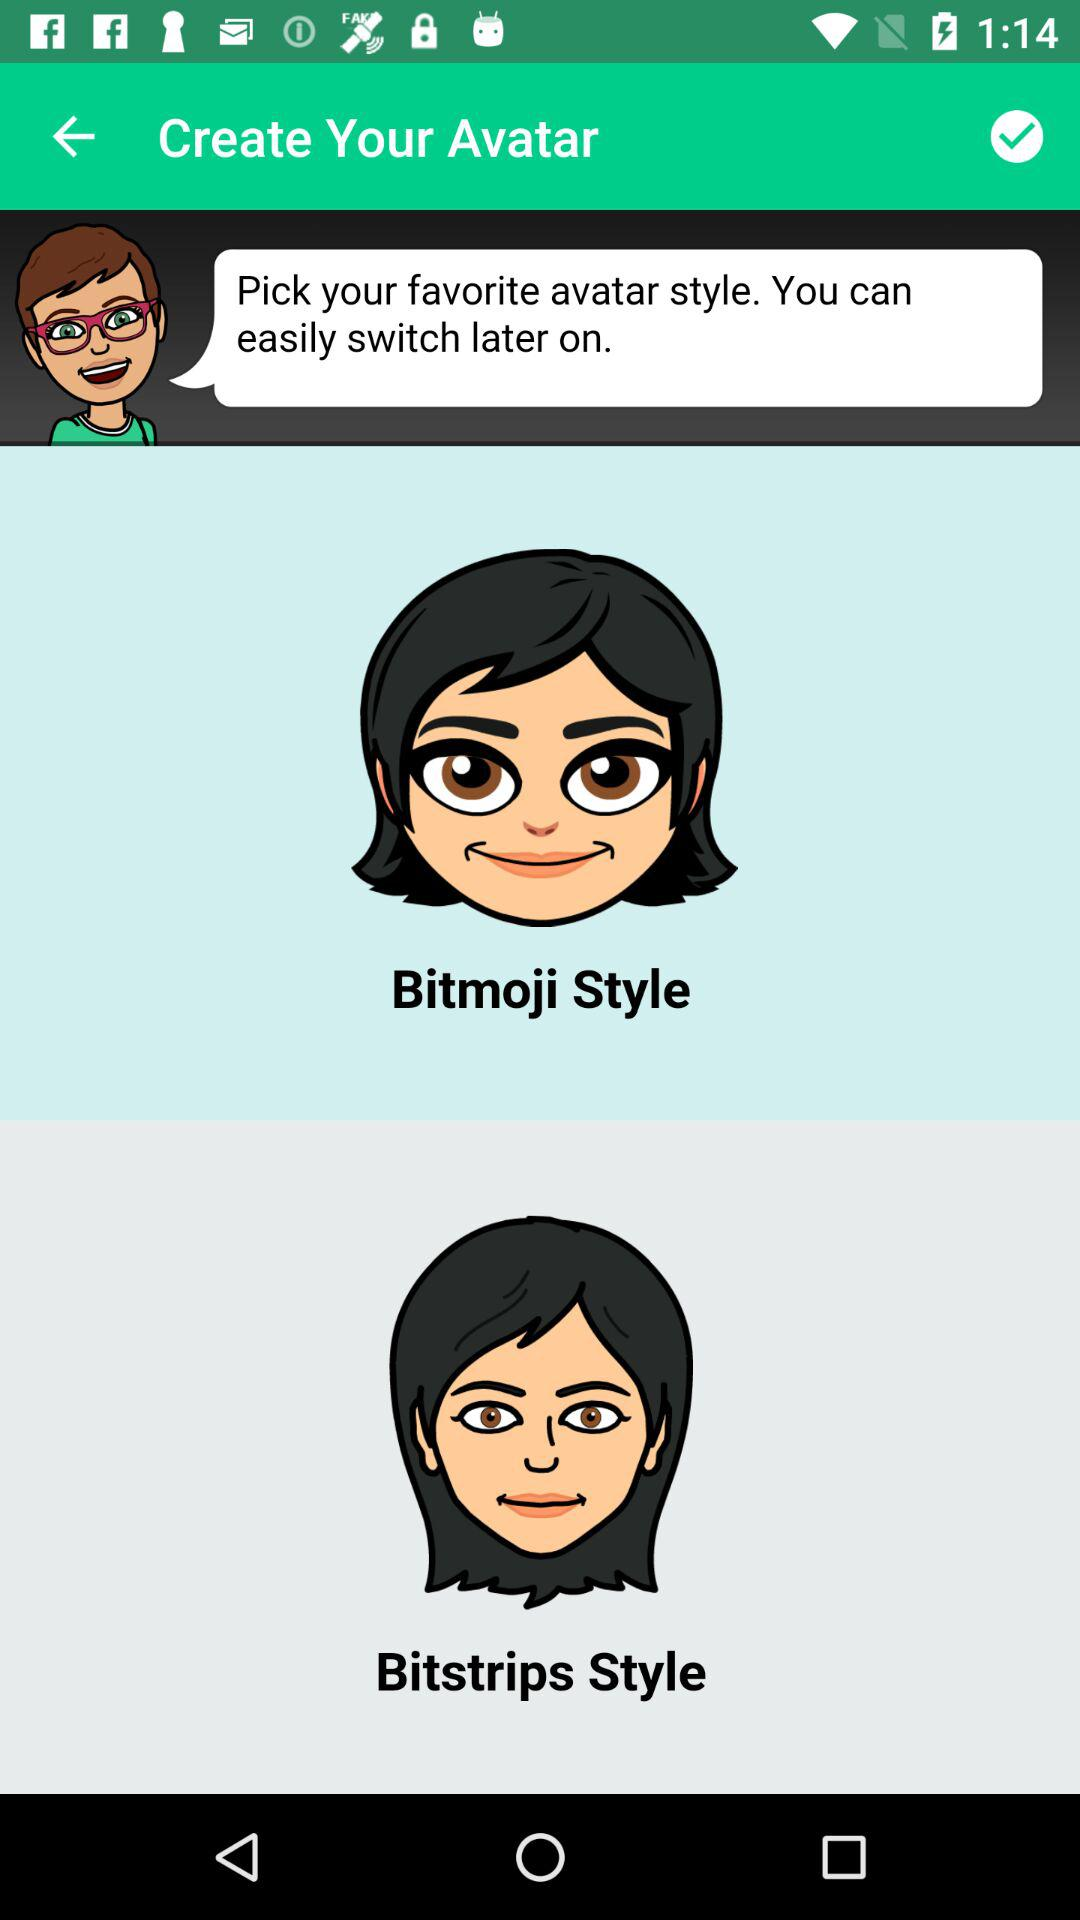How many different avatar styles are there?
Answer the question using a single word or phrase. 2 